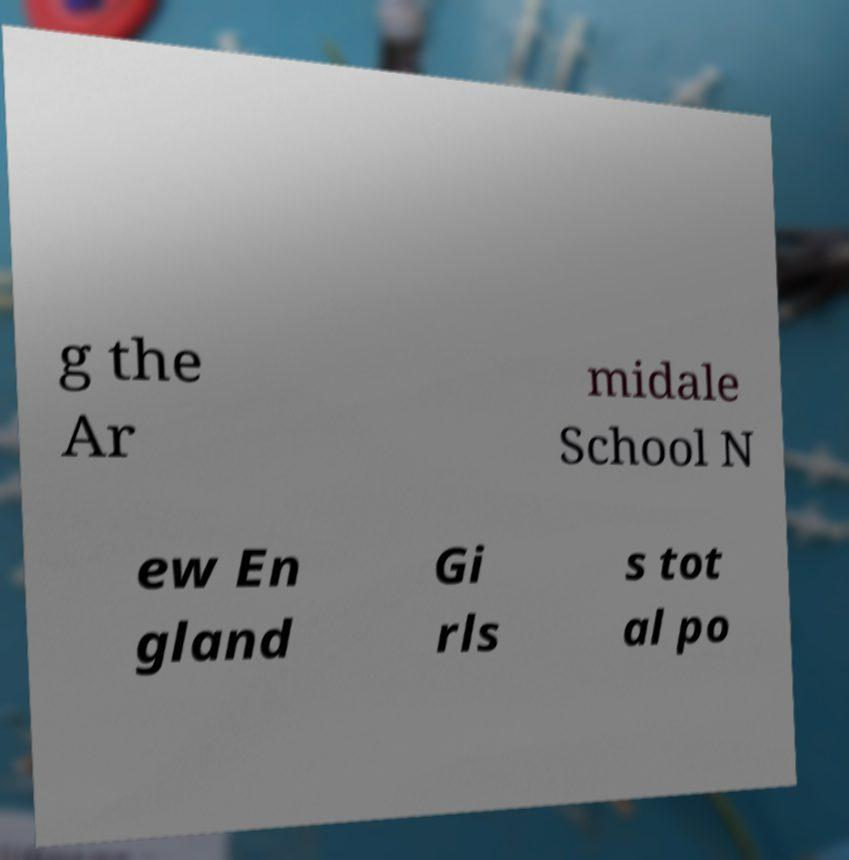Please read and relay the text visible in this image. What does it say? g the Ar midale School N ew En gland Gi rls s tot al po 